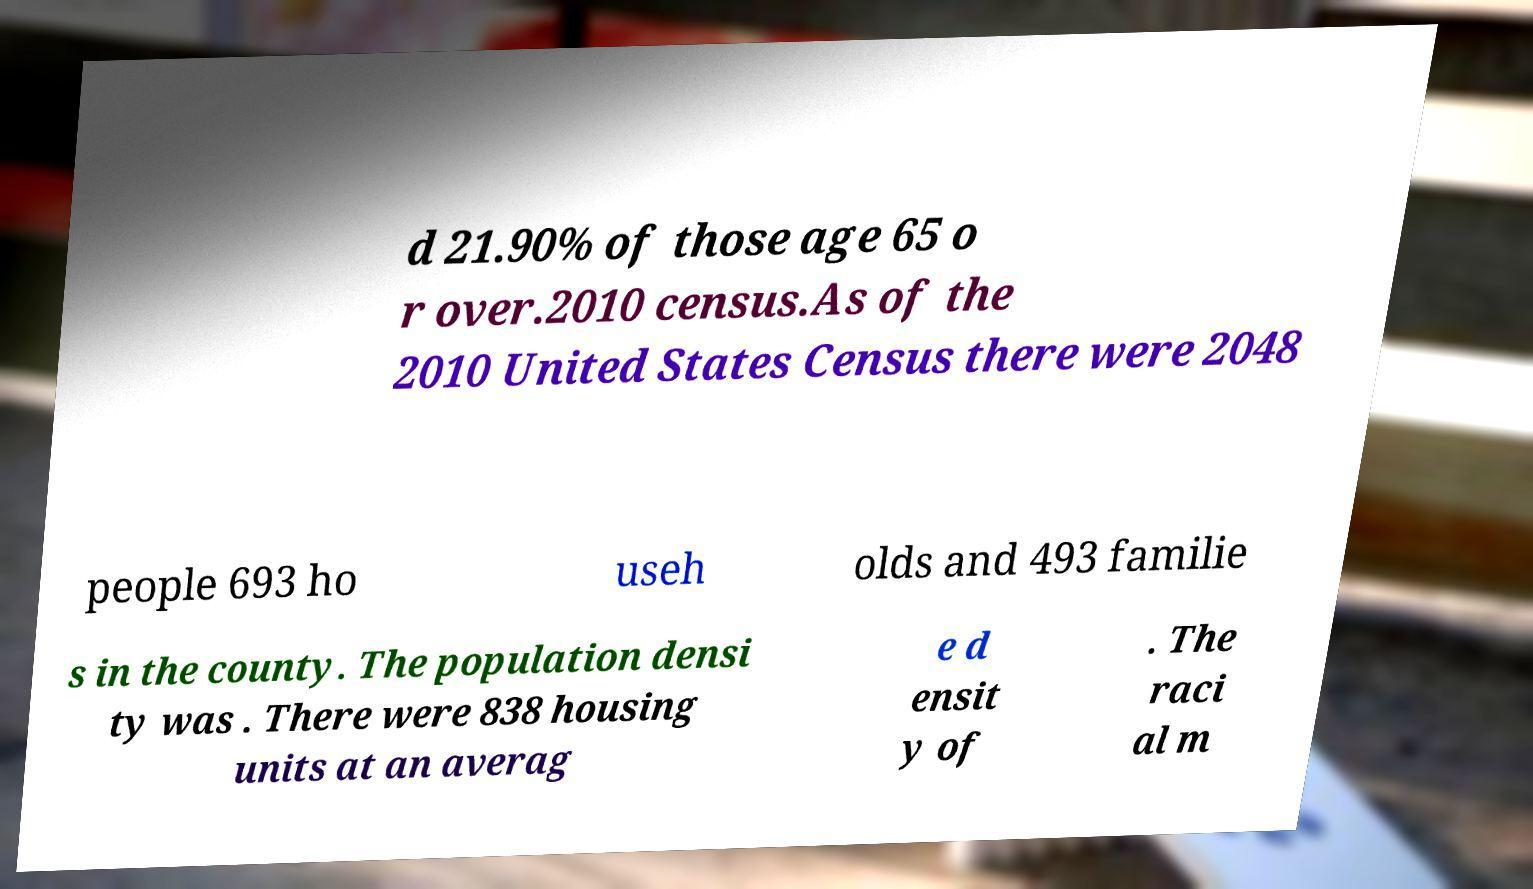Please read and relay the text visible in this image. What does it say? d 21.90% of those age 65 o r over.2010 census.As of the 2010 United States Census there were 2048 people 693 ho useh olds and 493 familie s in the county. The population densi ty was . There were 838 housing units at an averag e d ensit y of . The raci al m 